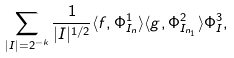<formula> <loc_0><loc_0><loc_500><loc_500>\sum _ { | I | = 2 ^ { - k } } \frac { 1 } { | I | ^ { 1 / 2 } } \langle f , \Phi ^ { 1 } _ { I _ { n } } \rangle \langle g , \Phi ^ { 2 } _ { I _ { n _ { 1 } } } \rangle \Phi ^ { 3 } _ { I } ,</formula> 